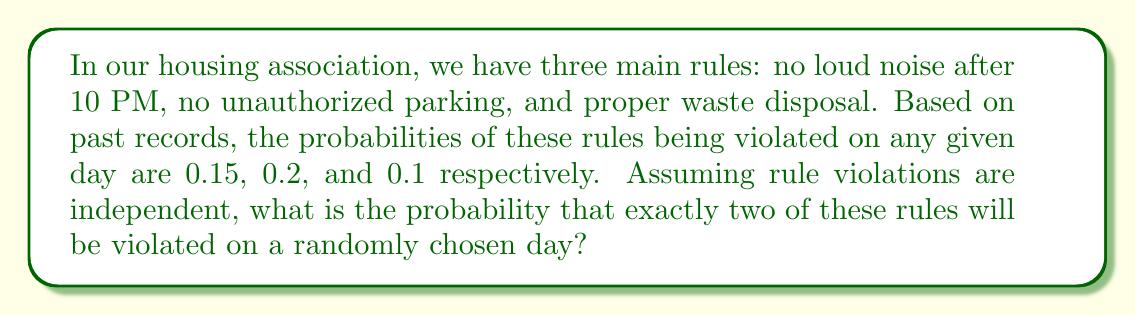Teach me how to tackle this problem. Let's approach this step-by-step using the concepts of probability and combinatorics:

1) First, we need to identify the probability of each rule being violated:
   P(noise violation) = 0.15
   P(parking violation) = 0.2
   P(waste disposal violation) = 0.1

2) We want the probability of exactly two rules being violated. This can happen in three ways:
   - Noise and parking violations (but not waste)
   - Noise and waste violations (but not parking)
   - Parking and waste violations (but not noise)

3) For each of these scenarios, we need to calculate:
   P(two specific violations) × P(no violation for the third rule)

4) Let's calculate each scenario:

   a) Noise and parking violations:
      $0.15 \times 0.2 \times (1-0.1) = 0.15 \times 0.2 \times 0.9 = 0.027$

   b) Noise and waste violations:
      $0.15 \times 0.1 \times (1-0.2) = 0.15 \times 0.1 \times 0.8 = 0.012$

   c) Parking and waste violations:
      $0.2 \times 0.1 \times (1-0.15) = 0.2 \times 0.1 \times 0.85 = 0.017$

5) The total probability is the sum of these three scenarios:

   $P(\text{exactly two violations}) = 0.027 + 0.012 + 0.017 = 0.056$

Therefore, the probability of exactly two rules being violated on a randomly chosen day is 0.056 or 5.6%.
Answer: 0.056 